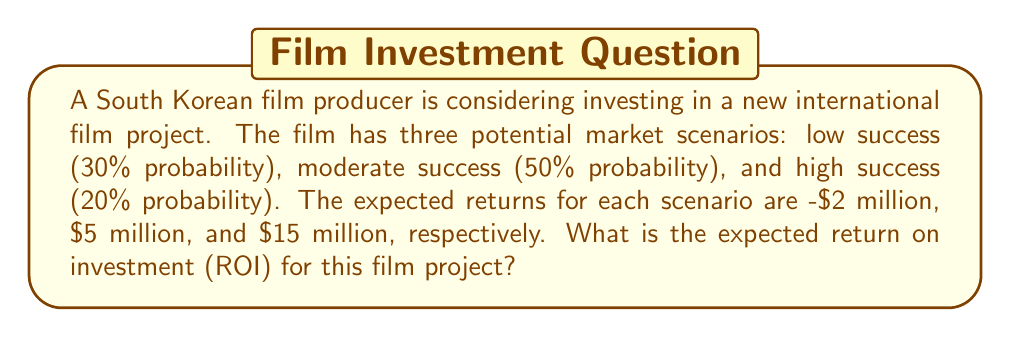Help me with this question. To solve this problem, we need to calculate the expected value of the return on investment. We'll follow these steps:

1. Identify the probability and return for each scenario:
   - Low success: $P(L) = 0.30$, $R(L) = -\$2$ million
   - Moderate success: $P(M) = 0.50$, $R(M) = \$5$ million
   - High success: $P(H) = 0.20$, $R(H) = \$15$ million

2. Calculate the expected value using the formula:
   $$E(R) = \sum_{i} P(i) \cdot R(i)$$
   Where $E(R)$ is the expected return, $P(i)$ is the probability of each scenario, and $R(i)$ is the return for each scenario.

3. Plug in the values:
   $$\begin{align}
   E(R) &= P(L) \cdot R(L) + P(M) \cdot R(M) + P(H) \cdot R(H) \\
   &= 0.30 \cdot (-\$2\text{ million}) + 0.50 \cdot (\$5\text{ million}) + 0.20 \cdot (\$15\text{ million})
   \end{align}$$

4. Perform the calculations:
   $$\begin{align}
   E(R) &= -\$0.6\text{ million} + \$2.5\text{ million} + \$3\text{ million} \\
   &= \$4.9\text{ million}
   \end{align}$$

Therefore, the expected return on investment for this film project is $4.9 million.
Answer: $4.9 million 